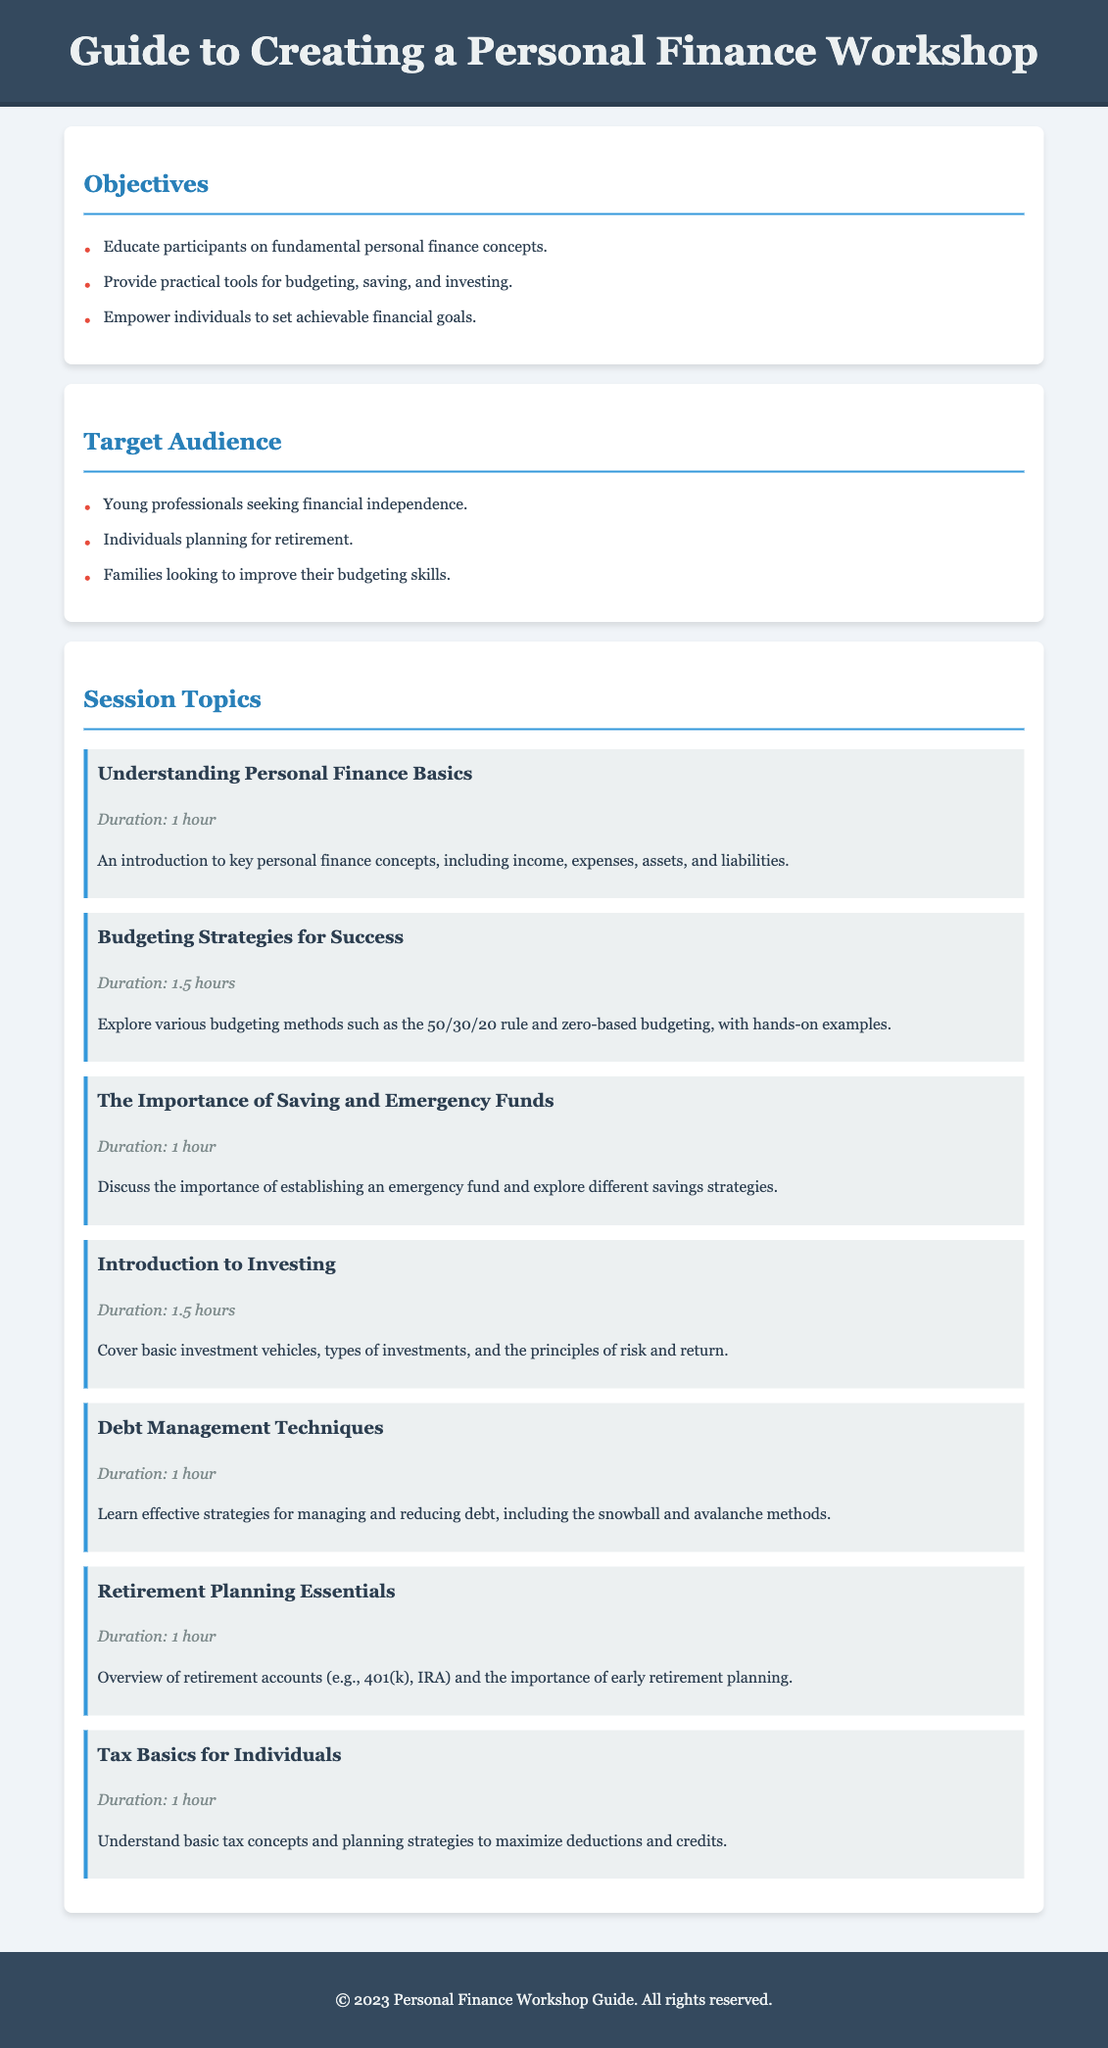What are the objectives of the workshop? The objectives are listed in a bullet format in the document, aiming to educate participants on personal finance concepts and provide practical tools.
Answer: Educate participants on fundamental personal finance concepts, provide practical tools for budgeting, saving, and investing, empower individuals to set achievable financial goals Who is the target audience for the workshop? The target audience includes groups of people identified in bullet points in the document looking for financial education.
Answer: Young professionals seeking financial independence, individuals planning for retirement, families looking to improve their budgeting skills How long is the session on budgeting strategies? The duration for the budgeting strategies session is clearly stated in the session topics section of the document.
Answer: 1.5 hours What is the first session topic listed? The first session topic is specified at the beginning of the session topics section in the document.
Answer: Understanding Personal Finance Basics Which session focuses on retirement planning? The session focusing on retirement planning is described among the session topics and includes details about planning for retirement.
Answer: Retirement Planning Essentials How many total session topics are there? The document lists out all the session topics, allowing for an easy count of the total number.
Answer: 7 What method is mentioned for debt management? The document elaborates on debt management techniques, identifying specific strategies highlighted in the session description.
Answer: Snowball and avalanche methods What color is used for the header background? The header background color is specified in the style section of the document.
Answer: #34495e 